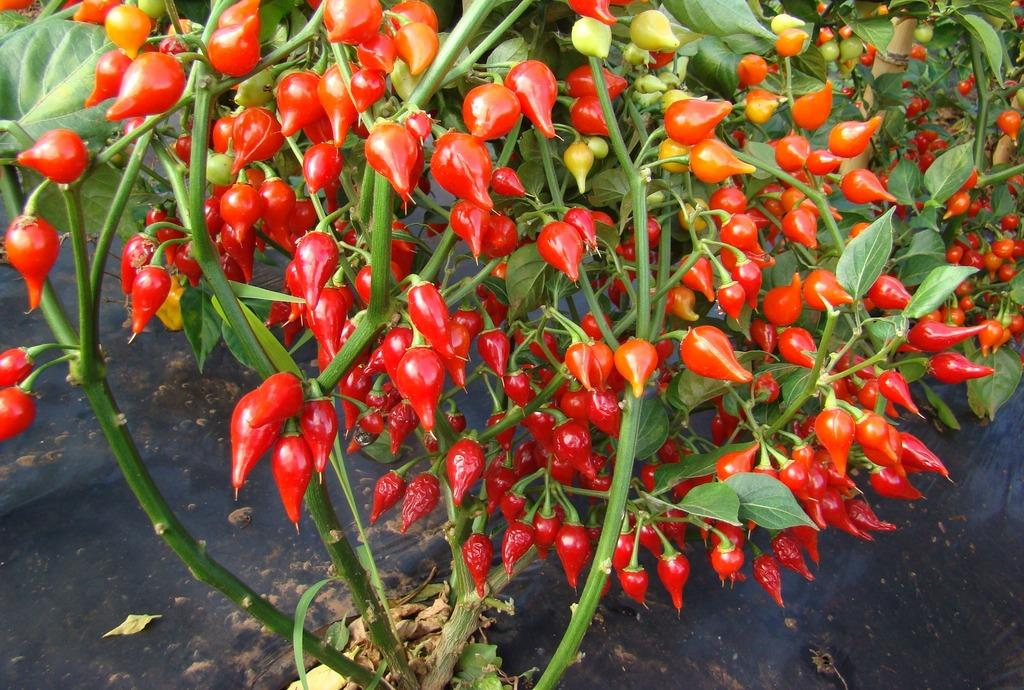What is the main subject of the image? There is a red chilli plant in the center of the image. Can you describe the color of the plant? The red chilli plant has a red color. Where is the plant located in the image? The red chilli plant is in the center of the image. What type of soap is being used to water the red chilli plant in the image? There is no soap present in the image, and the red chilli plant is not being watered. 